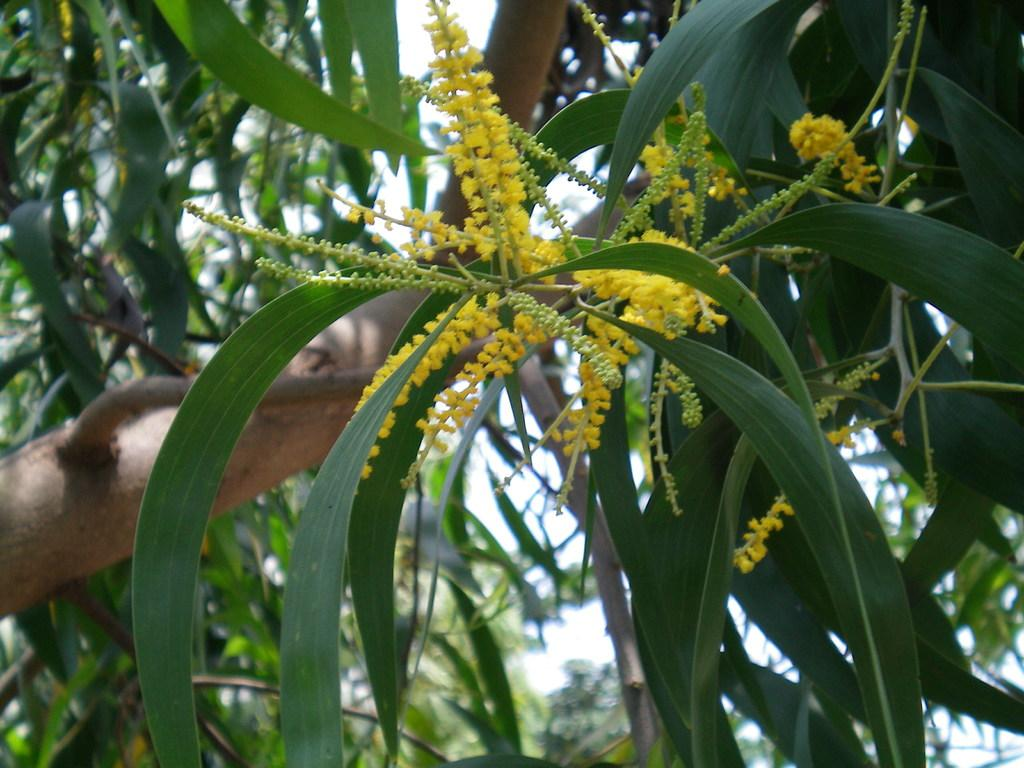What is located in the middle of the image? There are flowers in the middle of the image. What color are the flowers? The flowers are yellow. What can be seen in the background of the image? There are trees and the sky visible in the background of the image. Where is the vase located in the image? There is no vase present in the image. What type of station can be seen in the background of the image? There is no station visible in the image; it features flowers, trees, and the sky. 